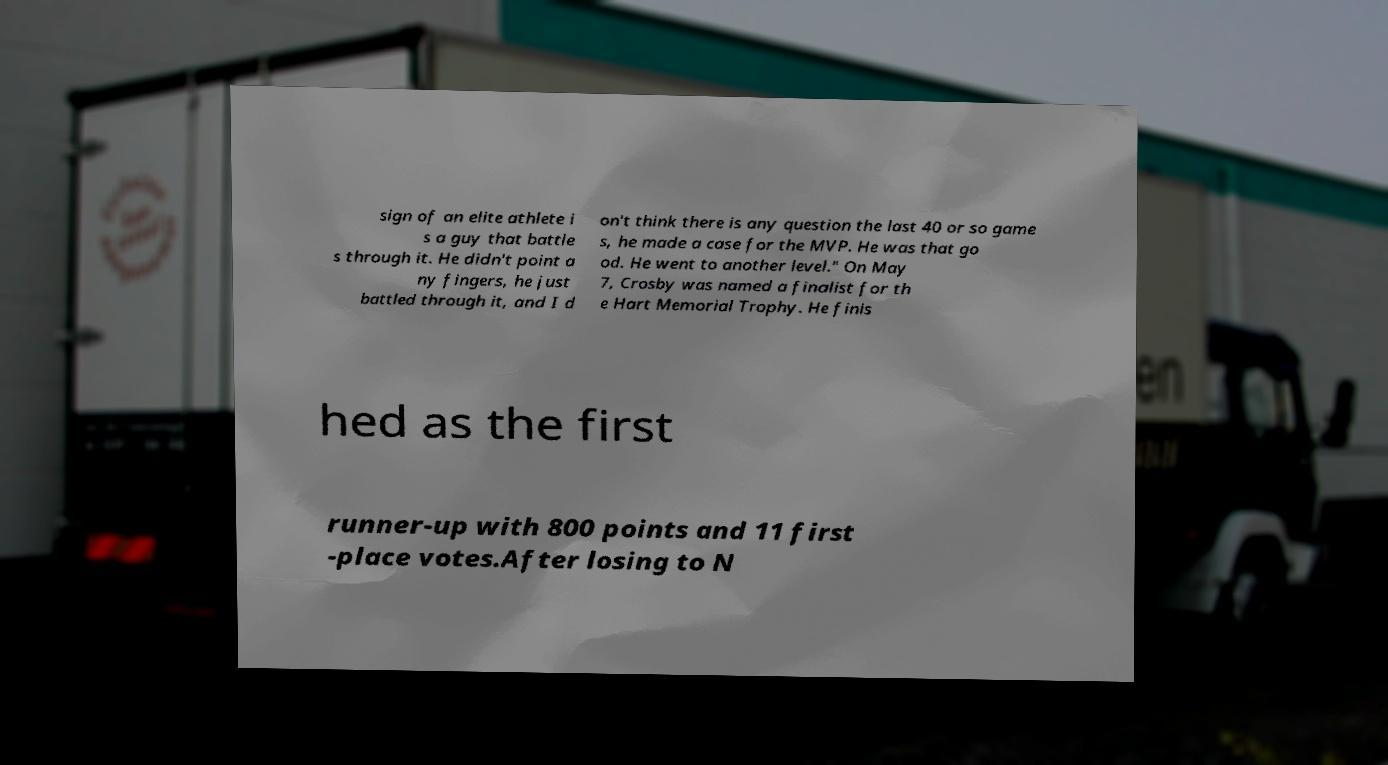For documentation purposes, I need the text within this image transcribed. Could you provide that? sign of an elite athlete i s a guy that battle s through it. He didn't point a ny fingers, he just battled through it, and I d on't think there is any question the last 40 or so game s, he made a case for the MVP. He was that go od. He went to another level." On May 7, Crosby was named a finalist for th e Hart Memorial Trophy. He finis hed as the first runner-up with 800 points and 11 first -place votes.After losing to N 